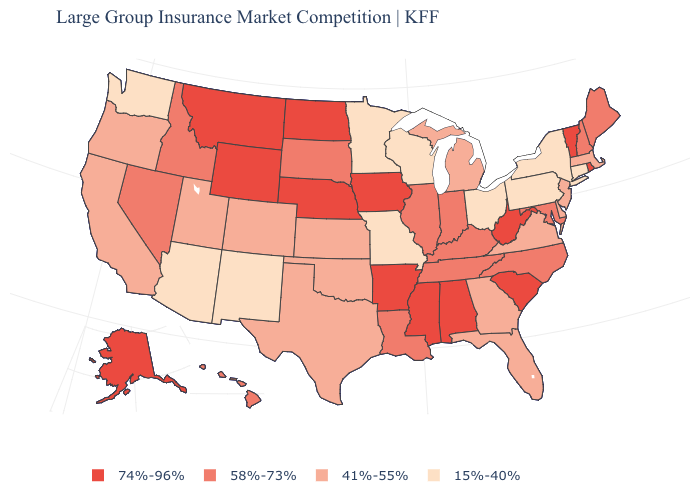What is the highest value in the USA?
Concise answer only. 74%-96%. What is the value of Indiana?
Quick response, please. 58%-73%. Does New York have the same value as Washington?
Be succinct. Yes. Among the states that border Kansas , which have the lowest value?
Be succinct. Missouri. What is the highest value in the USA?
Quick response, please. 74%-96%. What is the highest value in states that border Tennessee?
Keep it brief. 74%-96%. What is the highest value in the USA?
Give a very brief answer. 74%-96%. Does the first symbol in the legend represent the smallest category?
Concise answer only. No. Name the states that have a value in the range 58%-73%?
Quick response, please. Hawaii, Idaho, Illinois, Indiana, Kentucky, Louisiana, Maine, Maryland, Nevada, New Hampshire, North Carolina, South Dakota, Tennessee. Name the states that have a value in the range 58%-73%?
Be succinct. Hawaii, Idaho, Illinois, Indiana, Kentucky, Louisiana, Maine, Maryland, Nevada, New Hampshire, North Carolina, South Dakota, Tennessee. Does the first symbol in the legend represent the smallest category?
Be succinct. No. Among the states that border Massachusetts , which have the lowest value?
Write a very short answer. Connecticut, New York. What is the lowest value in states that border New Hampshire?
Write a very short answer. 41%-55%. Name the states that have a value in the range 41%-55%?
Short answer required. California, Colorado, Delaware, Florida, Georgia, Kansas, Massachusetts, Michigan, New Jersey, Oklahoma, Oregon, Texas, Utah, Virginia. 